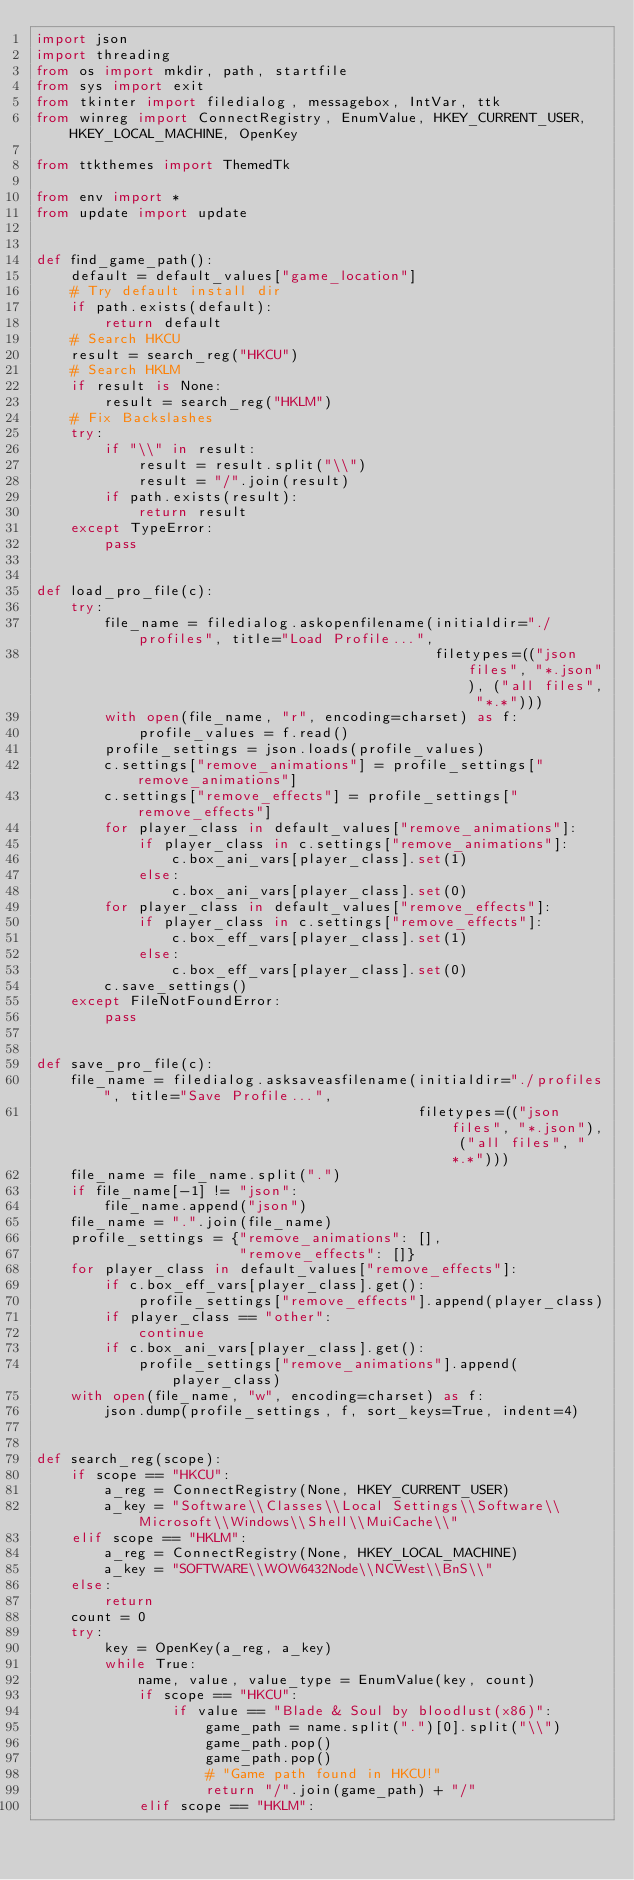<code> <loc_0><loc_0><loc_500><loc_500><_Python_>import json
import threading
from os import mkdir, path, startfile
from sys import exit
from tkinter import filedialog, messagebox, IntVar, ttk
from winreg import ConnectRegistry, EnumValue, HKEY_CURRENT_USER, HKEY_LOCAL_MACHINE, OpenKey

from ttkthemes import ThemedTk

from env import *
from update import update


def find_game_path():
    default = default_values["game_location"]
    # Try default install dir
    if path.exists(default):
        return default
    # Search HKCU
    result = search_reg("HKCU")
    # Search HKLM
    if result is None:
        result = search_reg("HKLM")
    # Fix Backslashes
    try:
        if "\\" in result:
            result = result.split("\\")
            result = "/".join(result)
        if path.exists(result):
            return result
    except TypeError:
        pass


def load_pro_file(c):
    try:
        file_name = filedialog.askopenfilename(initialdir="./profiles", title="Load Profile...",
                                               filetypes=(("json files", "*.json"), ("all files", "*.*")))
        with open(file_name, "r", encoding=charset) as f:
            profile_values = f.read()
        profile_settings = json.loads(profile_values)
        c.settings["remove_animations"] = profile_settings["remove_animations"]
        c.settings["remove_effects"] = profile_settings["remove_effects"]
        for player_class in default_values["remove_animations"]:
            if player_class in c.settings["remove_animations"]:
                c.box_ani_vars[player_class].set(1)
            else:
                c.box_ani_vars[player_class].set(0)
        for player_class in default_values["remove_effects"]:
            if player_class in c.settings["remove_effects"]:
                c.box_eff_vars[player_class].set(1)
            else:
                c.box_eff_vars[player_class].set(0)
        c.save_settings()
    except FileNotFoundError:
        pass


def save_pro_file(c):
    file_name = filedialog.asksaveasfilename(initialdir="./profiles", title="Save Profile...",
                                             filetypes=(("json files", "*.json"), ("all files", "*.*")))
    file_name = file_name.split(".")
    if file_name[-1] != "json":
        file_name.append("json")
    file_name = ".".join(file_name)
    profile_settings = {"remove_animations": [],
                        "remove_effects": []}
    for player_class in default_values["remove_effects"]:
        if c.box_eff_vars[player_class].get():
            profile_settings["remove_effects"].append(player_class)
        if player_class == "other":
            continue
        if c.box_ani_vars[player_class].get():
            profile_settings["remove_animations"].append(player_class)
    with open(file_name, "w", encoding=charset) as f:
        json.dump(profile_settings, f, sort_keys=True, indent=4)


def search_reg(scope):
    if scope == "HKCU":
        a_reg = ConnectRegistry(None, HKEY_CURRENT_USER)
        a_key = "Software\\Classes\\Local Settings\\Software\\Microsoft\\Windows\\Shell\\MuiCache\\"
    elif scope == "HKLM":
        a_reg = ConnectRegistry(None, HKEY_LOCAL_MACHINE)
        a_key = "SOFTWARE\\WOW6432Node\\NCWest\\BnS\\"
    else:
        return
    count = 0
    try:
        key = OpenKey(a_reg, a_key)
        while True:
            name, value, value_type = EnumValue(key, count)
            if scope == "HKCU":
                if value == "Blade & Soul by bloodlust(x86)":
                    game_path = name.split(".")[0].split("\\")
                    game_path.pop()
                    game_path.pop()
                    # "Game path found in HKCU!"
                    return "/".join(game_path) + "/"
            elif scope == "HKLM":</code> 